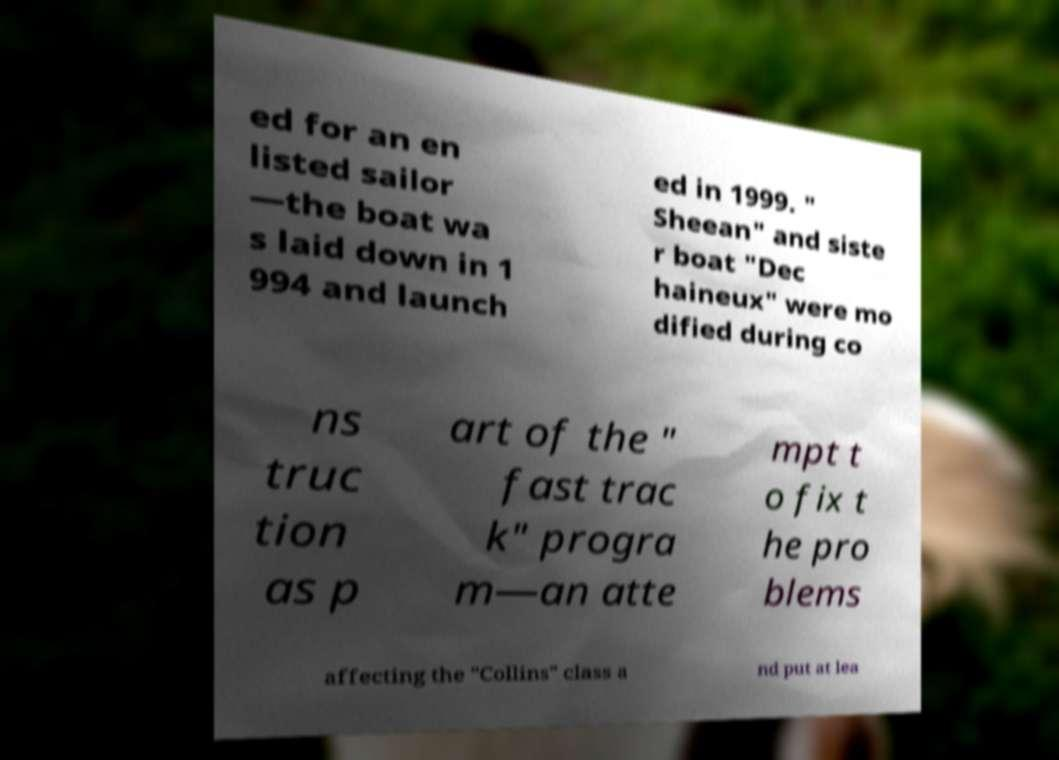I need the written content from this picture converted into text. Can you do that? ed for an en listed sailor —the boat wa s laid down in 1 994 and launch ed in 1999. " Sheean" and siste r boat "Dec haineux" were mo dified during co ns truc tion as p art of the " fast trac k" progra m—an atte mpt t o fix t he pro blems affecting the "Collins" class a nd put at lea 